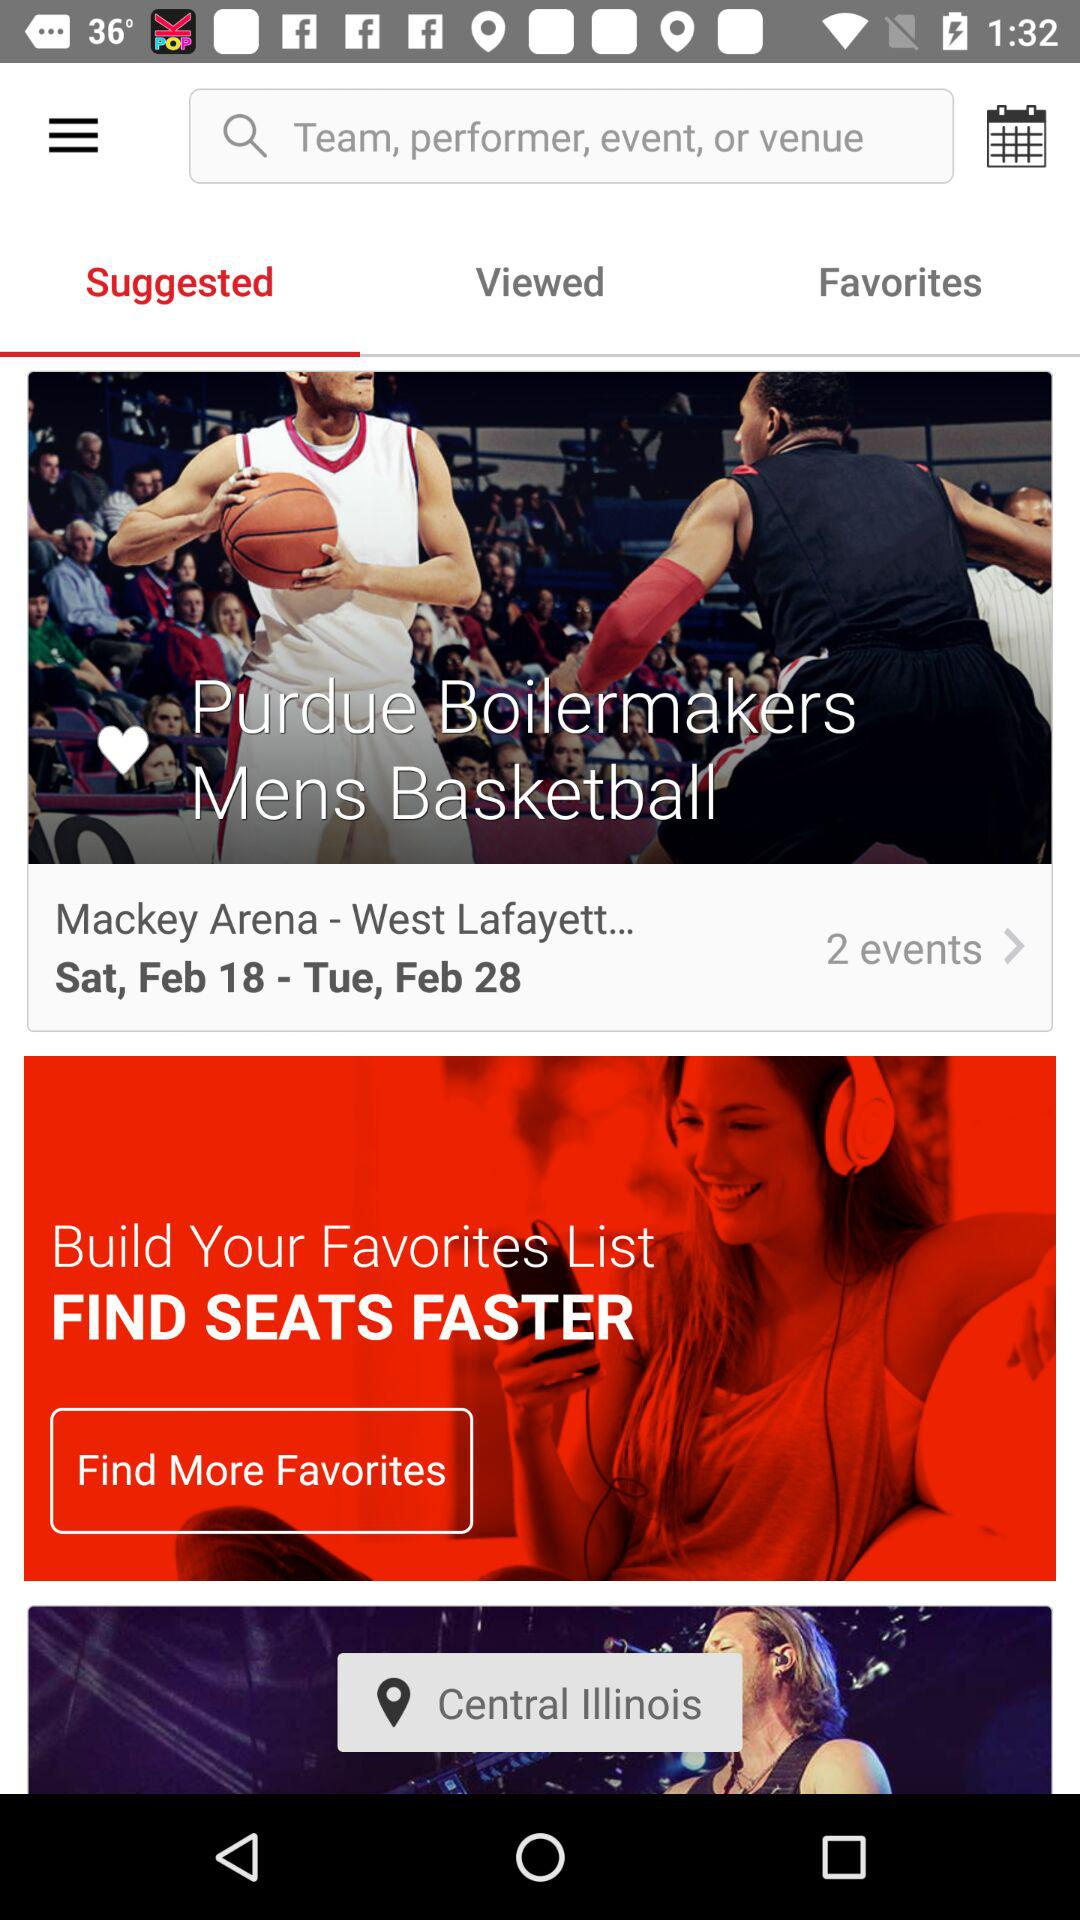Which tab am I using? You are using "Suggested" tab. 